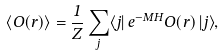Convert formula to latex. <formula><loc_0><loc_0><loc_500><loc_500>\langle O ( { r } ) \rangle = \frac { 1 } { Z } \sum _ { j } \langle j | \, e ^ { - M H } O ( { r } ) \, | j \rangle ,</formula> 